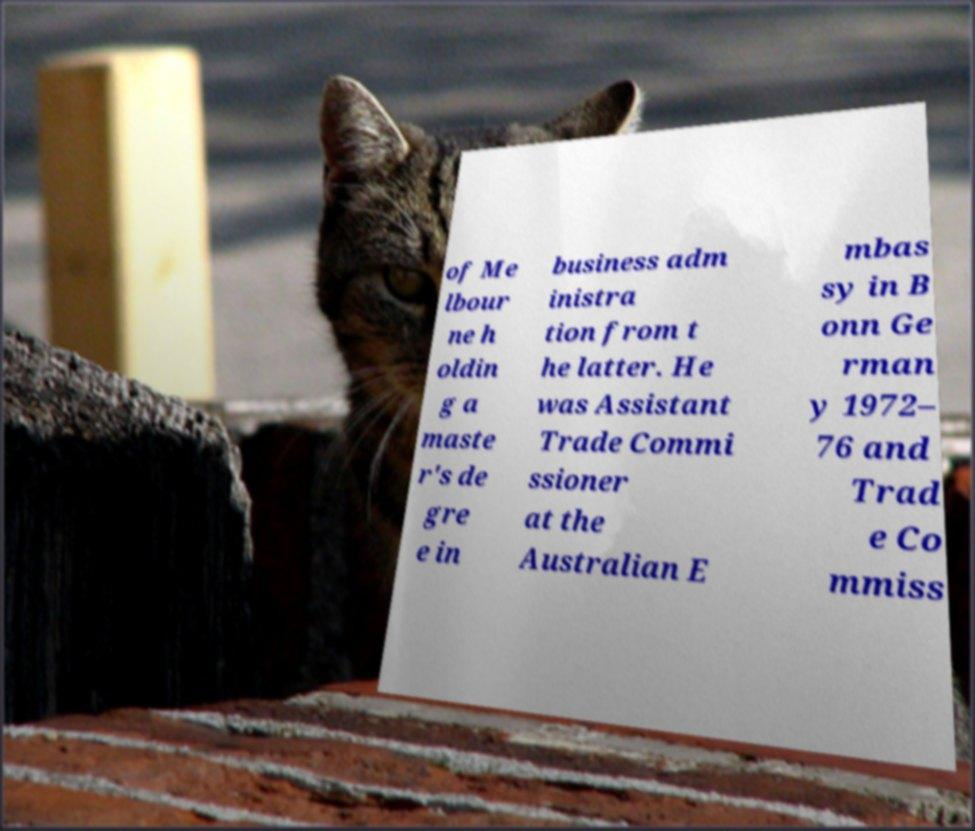There's text embedded in this image that I need extracted. Can you transcribe it verbatim? of Me lbour ne h oldin g a maste r's de gre e in business adm inistra tion from t he latter. He was Assistant Trade Commi ssioner at the Australian E mbas sy in B onn Ge rman y 1972– 76 and Trad e Co mmiss 